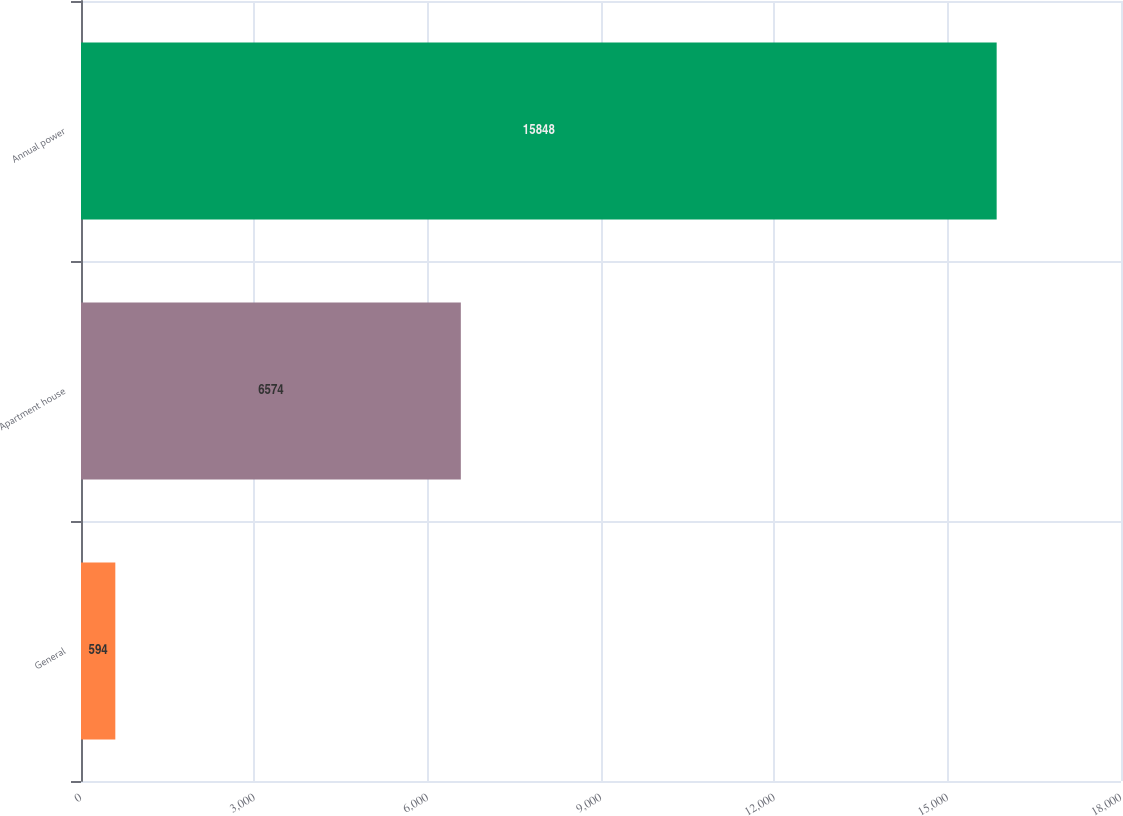<chart> <loc_0><loc_0><loc_500><loc_500><bar_chart><fcel>General<fcel>Apartment house<fcel>Annual power<nl><fcel>594<fcel>6574<fcel>15848<nl></chart> 